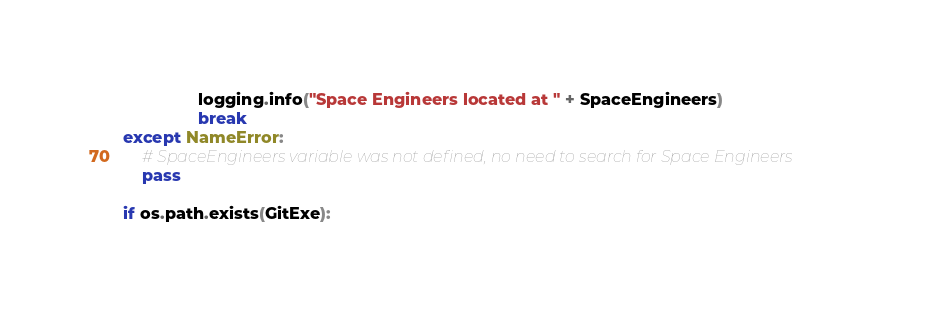<code> <loc_0><loc_0><loc_500><loc_500><_Python_>				logging.info("Space Engineers located at " + SpaceEngineers)
				break
except NameError:
	# SpaceEngineers variable was not defined, no need to search for Space Engineers
	pass

if os.path.exists(GitExe):</code> 